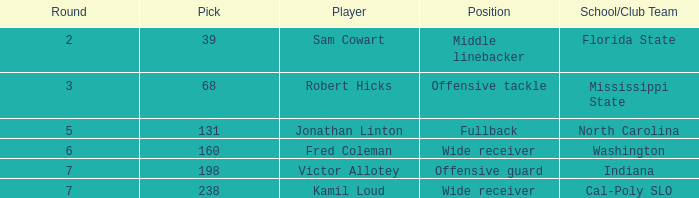Which School/Club Team has a Pick of 198? Indiana. 